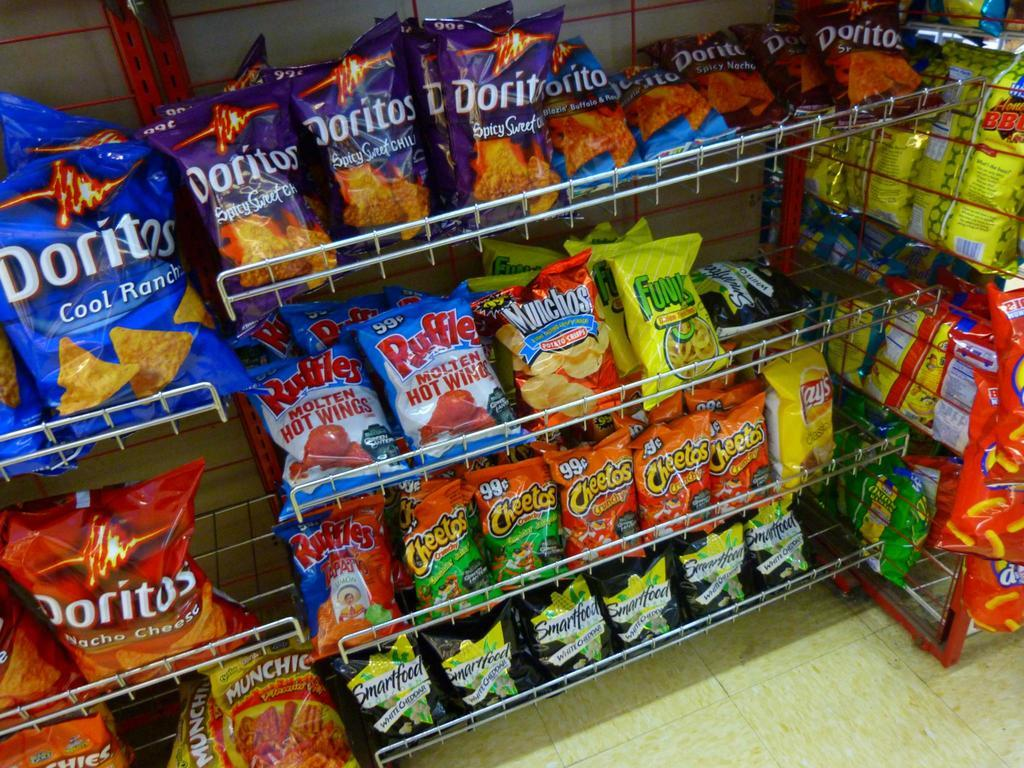<image>
Share a concise interpretation of the image provided. Bags of snack foods including Doritos in a variety of flavors are arranged on shelves. 